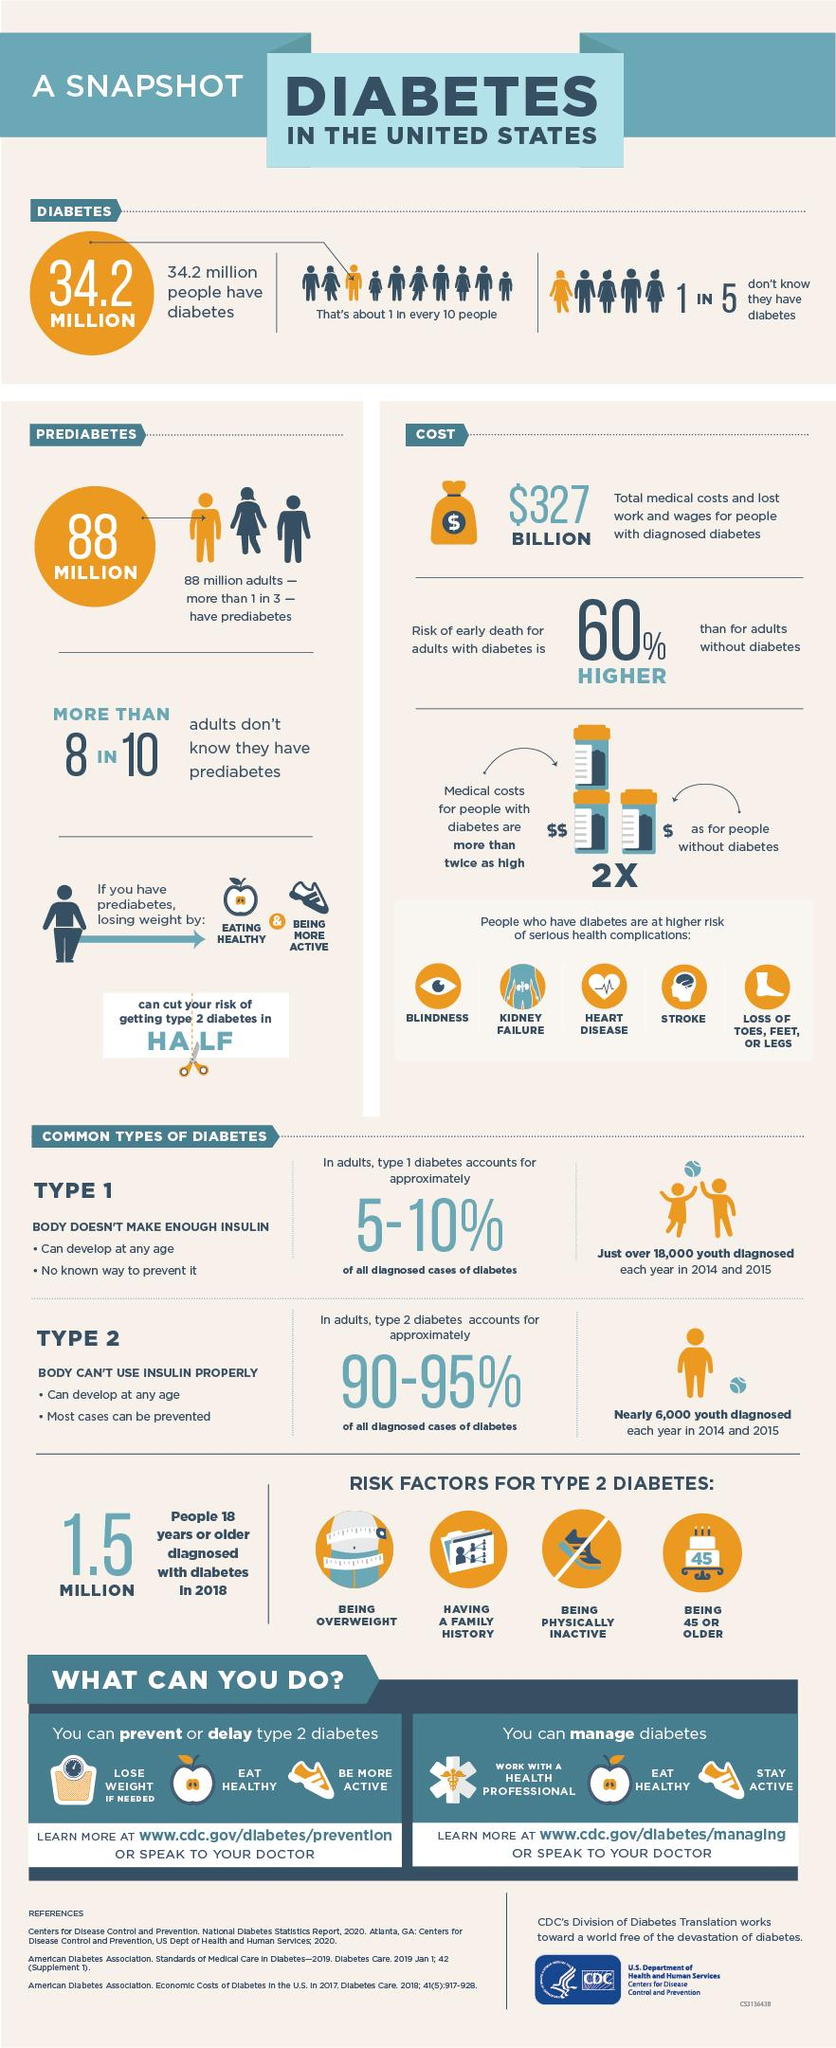Give some essential details in this illustration. Type 2 diabetes can be prevented. Approximately 10% of the population suffers from diabetes. Approximately 80% of adults who are unaware of their prediabetes status. Four categories of risk factors for Type 2 diabetes are commonly shown. Eating healthy and being more active can significantly reduce the risk of developing type 2 diabetes by approximately 50%. 